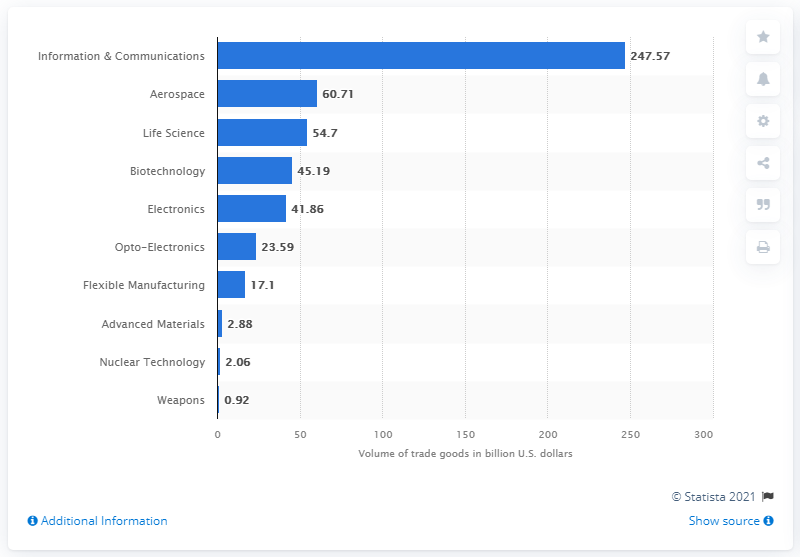Mention a couple of crucial points in this snapshot. In 2019, the United States imported aerospace products worth 60.71 billion dollars. 